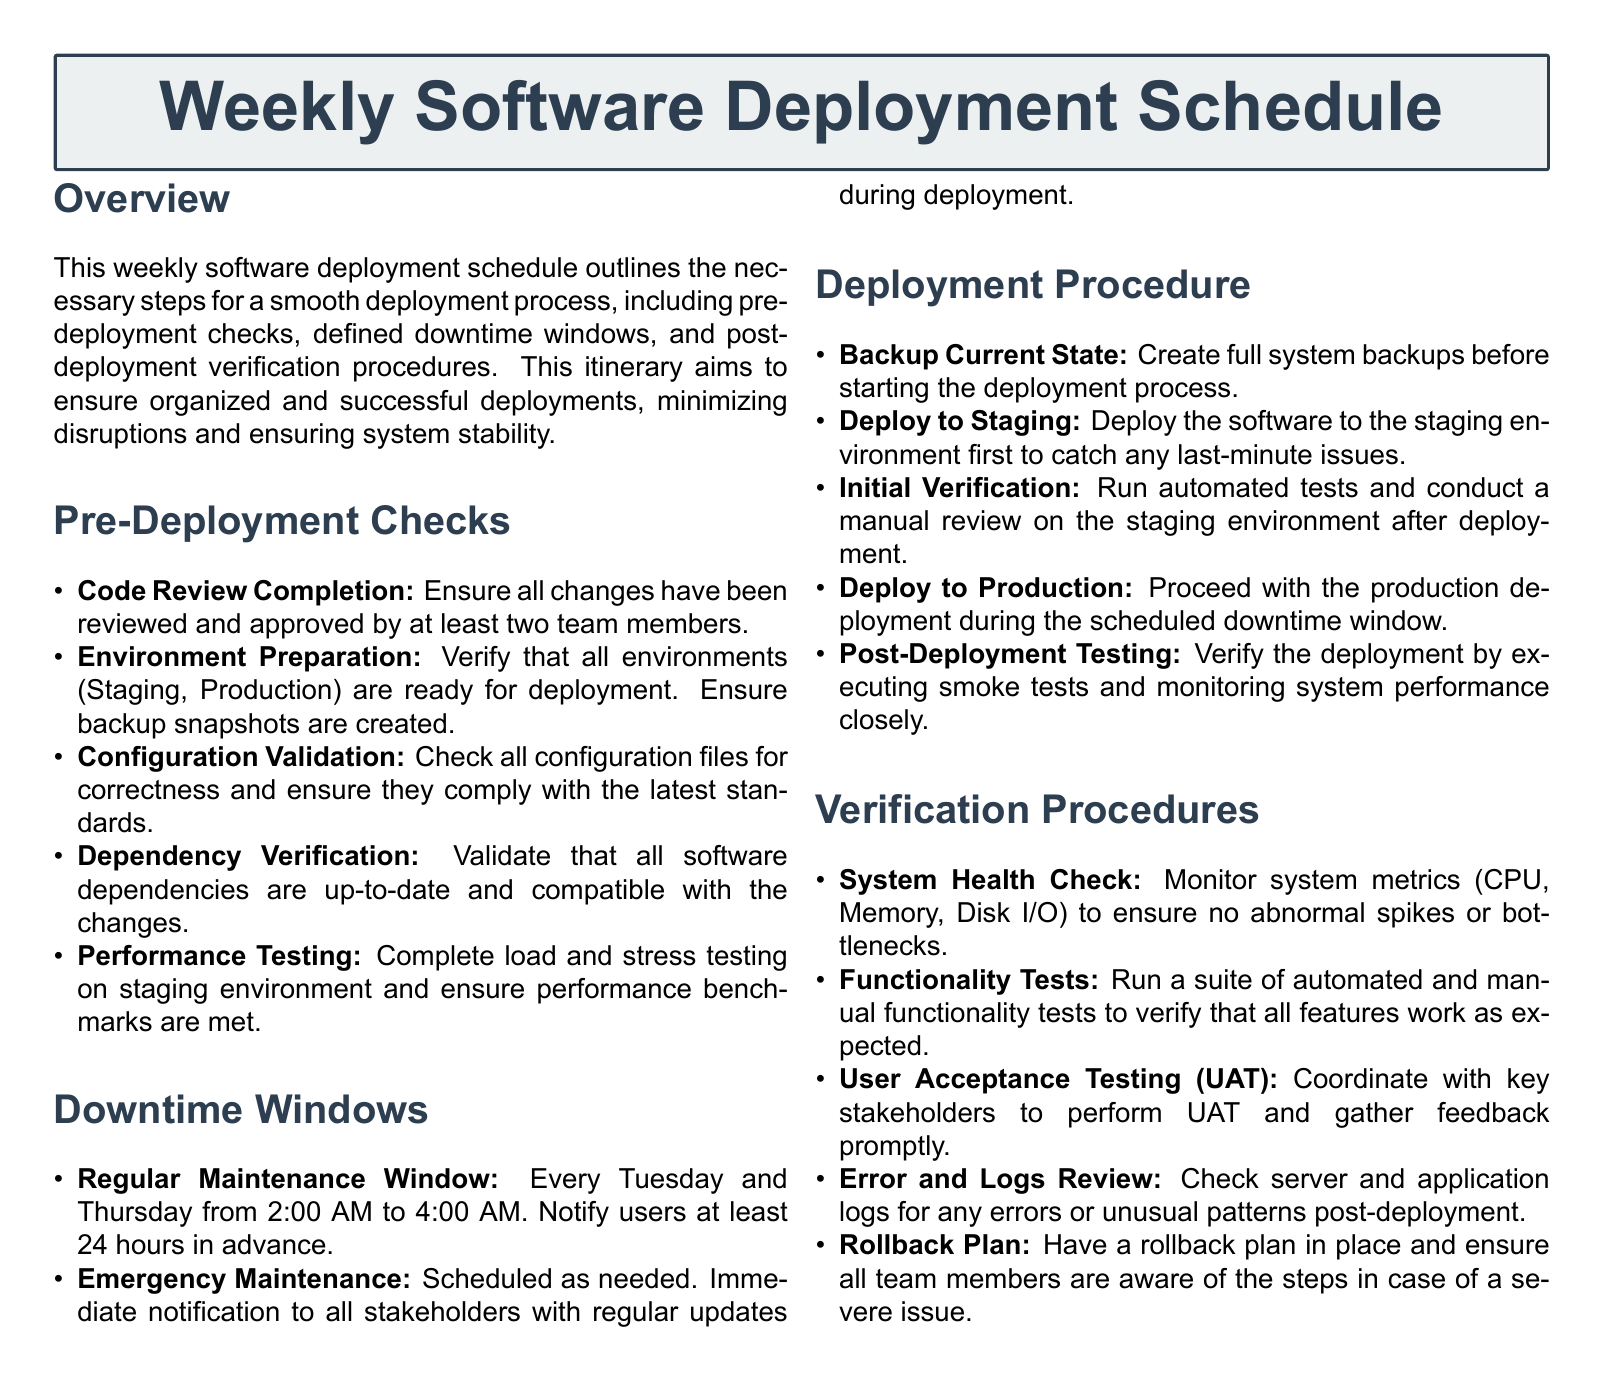What is the title of the document? The title is prominently displayed at the top of the document and states the main subject of the content.
Answer: Weekly Software Deployment Schedule What day of the week is the Regular Maintenance Window scheduled? The document specifies that the regular maintenance occurs on specific days of the week.
Answer: Tuesday and Thursday What is the duration of the Regular Maintenance Window? The document outlines the time frame for the regular maintenance in specific hours.
Answer: 2:00 AM to 4:00 AM How many team members are required for Code Review Completion? The document specifies the number of approvals needed for code changes before deployment.
Answer: Two team members Which testing is emphasized for the staging environment? The document mentions specific tests that are crucial for the staging environment before moving to production.
Answer: Load and stress testing What is the purpose of the Rollback Plan? The document states why it is essential to have a rollback plan and its significance during deployment.
Answer: In case of a severe issue How often should a System Health Check be performed? The document prescribes a type of check that involves monitoring system metrics post-deployment.
Answer: After deployment What is required before deploying to Production? The document lists essential steps that need to be taken before proceeding to the production deployment phase.
Answer: Full system backups What type of testing should be coordinated with stakeholders? The document lists activities that engage stakeholders in verifying the deployment.
Answer: User Acceptance Testing (UAT) 